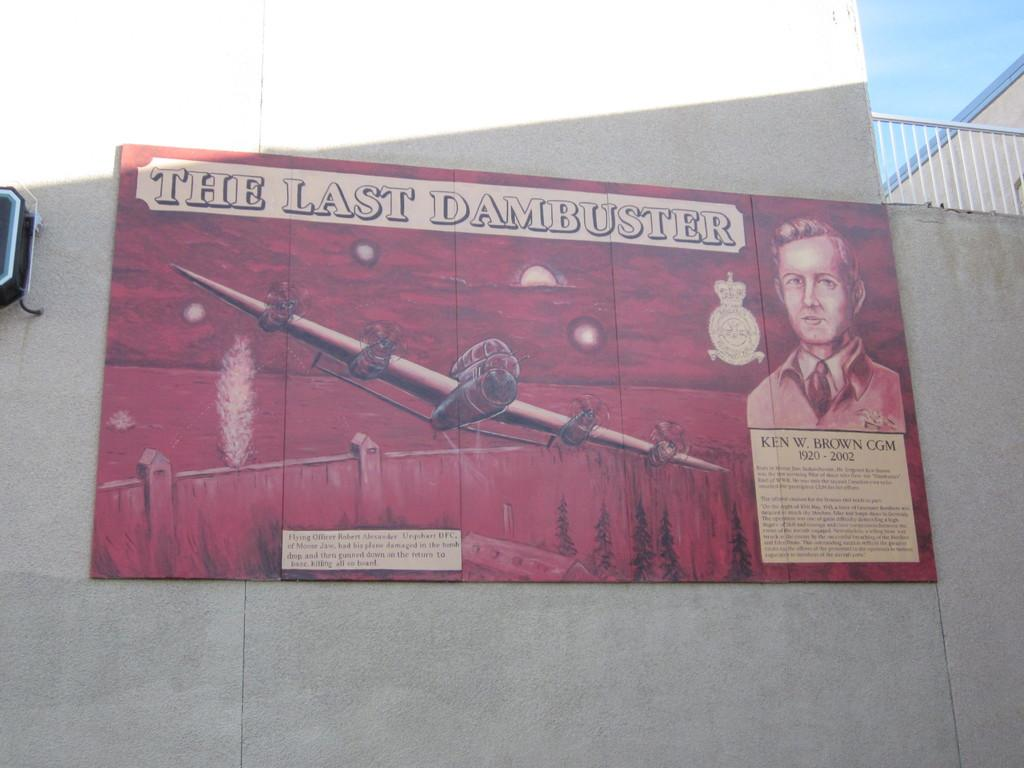<image>
Describe the image concisely. A red billboard showing a WW2 fighter plane going over a dam with the words "The Last Dambuster" written at the top. 